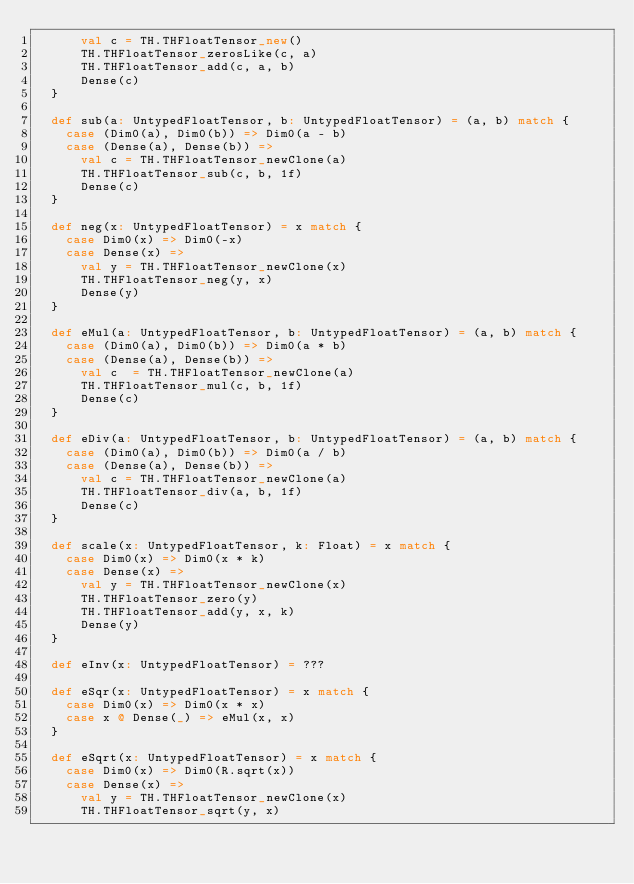Convert code to text. <code><loc_0><loc_0><loc_500><loc_500><_Scala_>      val c = TH.THFloatTensor_new()
      TH.THFloatTensor_zerosLike(c, a)
      TH.THFloatTensor_add(c, a, b)
      Dense(c)
  }

  def sub(a: UntypedFloatTensor, b: UntypedFloatTensor) = (a, b) match {
    case (Dim0(a), Dim0(b)) => Dim0(a - b)
    case (Dense(a), Dense(b)) =>
      val c = TH.THFloatTensor_newClone(a)
      TH.THFloatTensor_sub(c, b, 1f)
      Dense(c)
  }

  def neg(x: UntypedFloatTensor) = x match {
    case Dim0(x) => Dim0(-x)
    case Dense(x) =>
      val y = TH.THFloatTensor_newClone(x)
      TH.THFloatTensor_neg(y, x)
      Dense(y)
  }

  def eMul(a: UntypedFloatTensor, b: UntypedFloatTensor) = (a, b) match {
    case (Dim0(a), Dim0(b)) => Dim0(a * b)
    case (Dense(a), Dense(b)) =>
      val c  = TH.THFloatTensor_newClone(a)
      TH.THFloatTensor_mul(c, b, 1f)
      Dense(c)
  }

  def eDiv(a: UntypedFloatTensor, b: UntypedFloatTensor) = (a, b) match {
    case (Dim0(a), Dim0(b)) => Dim0(a / b)
    case (Dense(a), Dense(b)) =>
      val c = TH.THFloatTensor_newClone(a)
      TH.THFloatTensor_div(a, b, 1f)
      Dense(c)
  }

  def scale(x: UntypedFloatTensor, k: Float) = x match {
    case Dim0(x) => Dim0(x * k)
    case Dense(x) =>
      val y = TH.THFloatTensor_newClone(x)
      TH.THFloatTensor_zero(y)
      TH.THFloatTensor_add(y, x, k)
      Dense(y)
  }

  def eInv(x: UntypedFloatTensor) = ???

  def eSqr(x: UntypedFloatTensor) = x match {
    case Dim0(x) => Dim0(x * x)
    case x @ Dense(_) => eMul(x, x)
  }

  def eSqrt(x: UntypedFloatTensor) = x match {
    case Dim0(x) => Dim0(R.sqrt(x))
    case Dense(x) =>
      val y = TH.THFloatTensor_newClone(x)
      TH.THFloatTensor_sqrt(y, x)</code> 